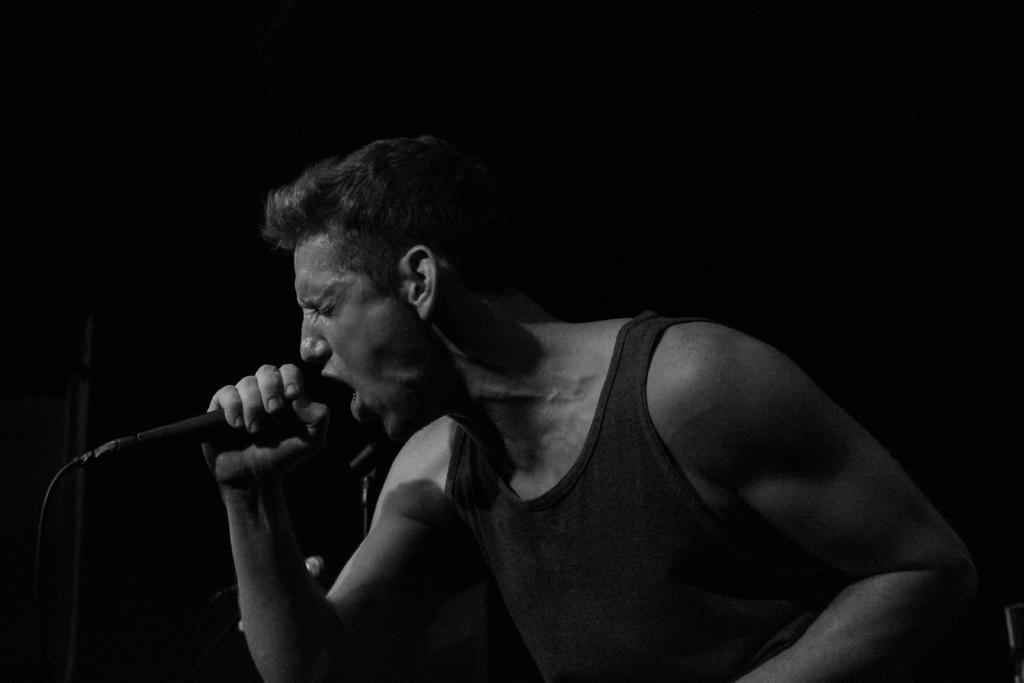Who is the main subject in the image? There is a man in the center of the image. What is the man holding in the image? The man is holding a mic. What can be seen in the background of the image? There is a stand in the background of the image. How far away is the book from the man in the image? There is no book present in the image, so it is not possible to determine the distance between the man and a book. 